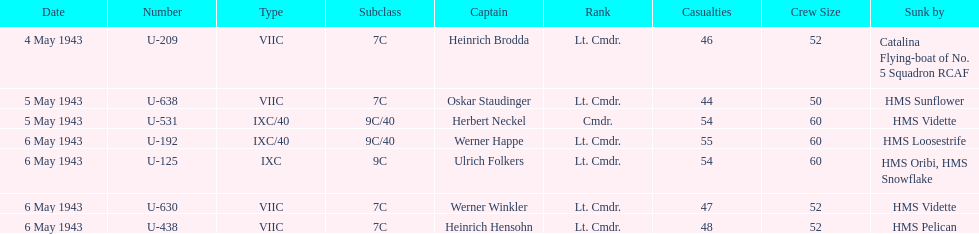Which u-boat had more than 54 casualties? U-192. 